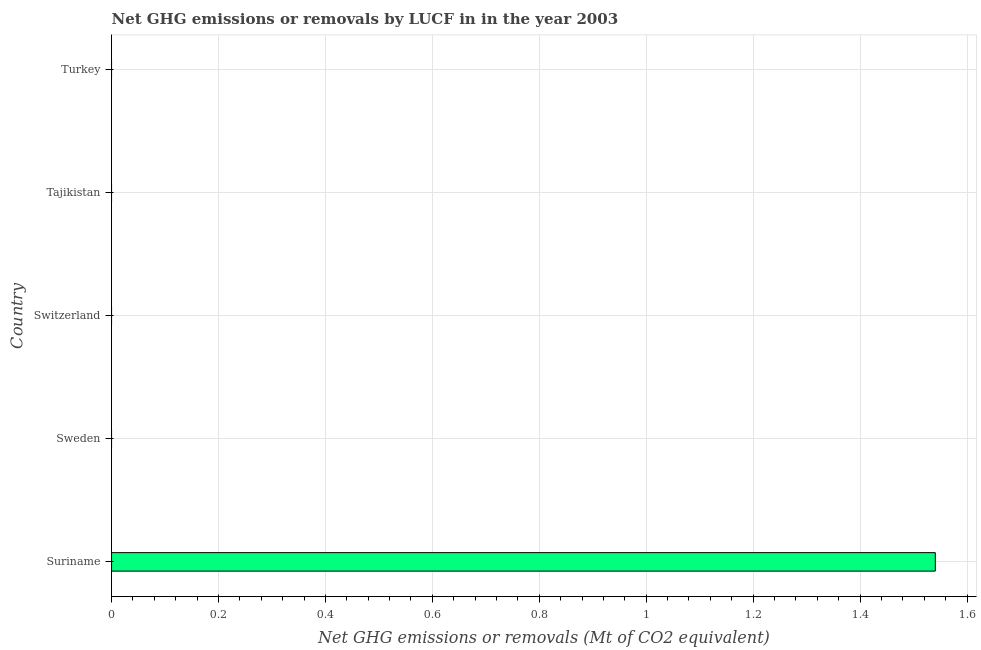Does the graph contain grids?
Ensure brevity in your answer.  Yes. What is the title of the graph?
Make the answer very short. Net GHG emissions or removals by LUCF in in the year 2003. What is the label or title of the X-axis?
Provide a succinct answer. Net GHG emissions or removals (Mt of CO2 equivalent). What is the label or title of the Y-axis?
Your answer should be very brief. Country. Across all countries, what is the maximum ghg net emissions or removals?
Your response must be concise. 1.54. Across all countries, what is the minimum ghg net emissions or removals?
Ensure brevity in your answer.  0. In which country was the ghg net emissions or removals maximum?
Your answer should be compact. Suriname. What is the sum of the ghg net emissions or removals?
Your answer should be very brief. 1.54. What is the average ghg net emissions or removals per country?
Your answer should be very brief. 0.31. What is the median ghg net emissions or removals?
Your response must be concise. 0. In how many countries, is the ghg net emissions or removals greater than 1.12 Mt?
Your answer should be compact. 1. What is the difference between the highest and the lowest ghg net emissions or removals?
Give a very brief answer. 1.54. In how many countries, is the ghg net emissions or removals greater than the average ghg net emissions or removals taken over all countries?
Keep it short and to the point. 1. Are all the bars in the graph horizontal?
Your answer should be very brief. Yes. What is the Net GHG emissions or removals (Mt of CO2 equivalent) in Suriname?
Provide a short and direct response. 1.54. What is the Net GHG emissions or removals (Mt of CO2 equivalent) in Switzerland?
Ensure brevity in your answer.  0. What is the Net GHG emissions or removals (Mt of CO2 equivalent) of Turkey?
Provide a succinct answer. 0. 